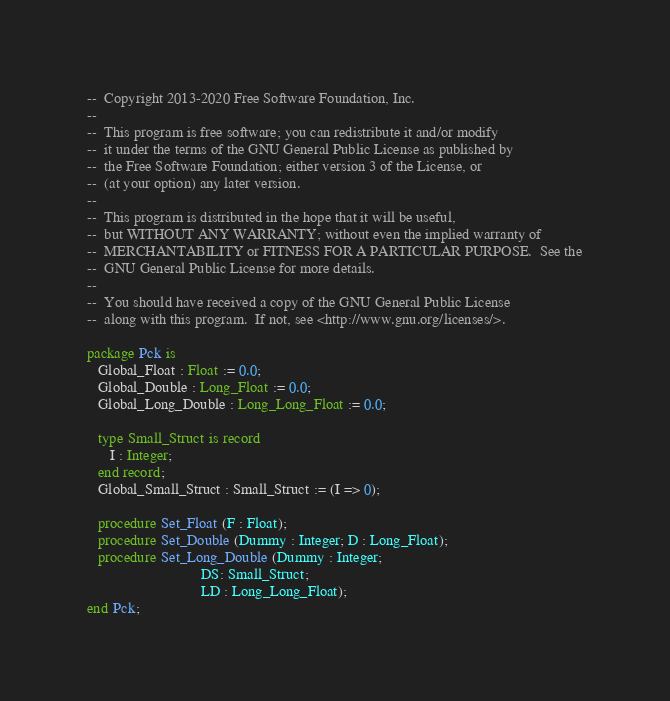<code> <loc_0><loc_0><loc_500><loc_500><_Ada_>--  Copyright 2013-2020 Free Software Foundation, Inc.
--
--  This program is free software; you can redistribute it and/or modify
--  it under the terms of the GNU General Public License as published by
--  the Free Software Foundation; either version 3 of the License, or
--  (at your option) any later version.
--
--  This program is distributed in the hope that it will be useful,
--  but WITHOUT ANY WARRANTY; without even the implied warranty of
--  MERCHANTABILITY or FITNESS FOR A PARTICULAR PURPOSE.  See the
--  GNU General Public License for more details.
--
--  You should have received a copy of the GNU General Public License
--  along with this program.  If not, see <http://www.gnu.org/licenses/>.

package Pck is
   Global_Float : Float := 0.0;
   Global_Double : Long_Float := 0.0;
   Global_Long_Double : Long_Long_Float := 0.0;

   type Small_Struct is record
      I : Integer;
   end record;
   Global_Small_Struct : Small_Struct := (I => 0);

   procedure Set_Float (F : Float);
   procedure Set_Double (Dummy : Integer; D : Long_Float);
   procedure Set_Long_Double (Dummy : Integer;
                              DS: Small_Struct;
                              LD : Long_Long_Float);
end Pck;
</code> 